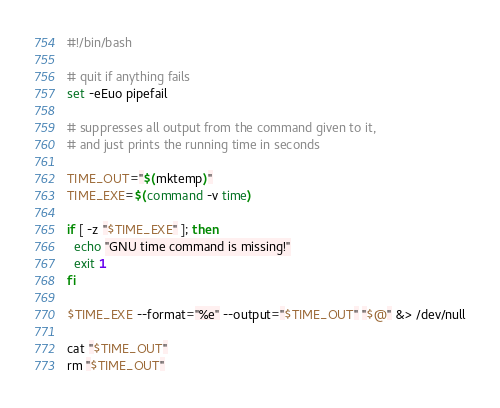Convert code to text. <code><loc_0><loc_0><loc_500><loc_500><_Bash_>#!/bin/bash

# quit if anything fails
set -eEuo pipefail

# suppresses all output from the command given to it,
# and just prints the running time in seconds

TIME_OUT="$(mktemp)"
TIME_EXE=$(command -v time)

if [ -z "$TIME_EXE" ]; then
  echo "GNU time command is missing!"
  exit 1
fi

$TIME_EXE --format="%e" --output="$TIME_OUT" "$@" &> /dev/null

cat "$TIME_OUT"
rm "$TIME_OUT"
</code> 